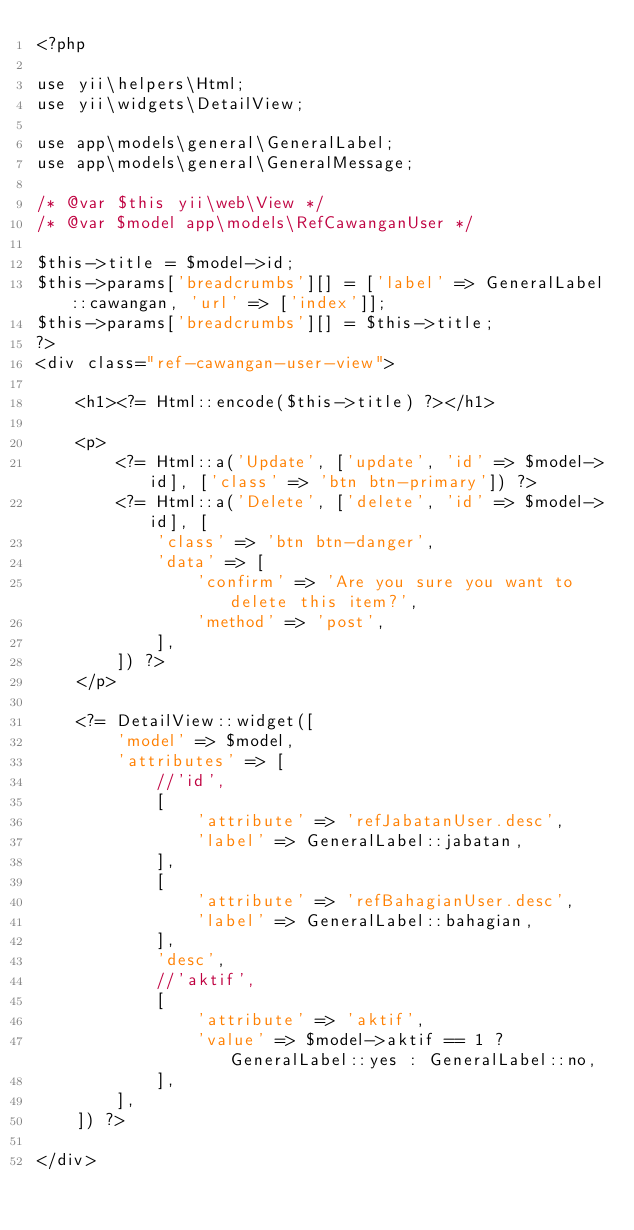<code> <loc_0><loc_0><loc_500><loc_500><_PHP_><?php

use yii\helpers\Html;
use yii\widgets\DetailView;

use app\models\general\GeneralLabel;
use app\models\general\GeneralMessage;

/* @var $this yii\web\View */
/* @var $model app\models\RefCawanganUser */

$this->title = $model->id;
$this->params['breadcrumbs'][] = ['label' => GeneralLabel::cawangan, 'url' => ['index']];
$this->params['breadcrumbs'][] = $this->title;
?>
<div class="ref-cawangan-user-view">

    <h1><?= Html::encode($this->title) ?></h1>

    <p>
        <?= Html::a('Update', ['update', 'id' => $model->id], ['class' => 'btn btn-primary']) ?>
        <?= Html::a('Delete', ['delete', 'id' => $model->id], [
            'class' => 'btn btn-danger',
            'data' => [
                'confirm' => 'Are you sure you want to delete this item?',
                'method' => 'post',
            ],
        ]) ?>
    </p>

    <?= DetailView::widget([
        'model' => $model,
        'attributes' => [
            //'id',
            [
                'attribute' => 'refJabatanUser.desc',
                'label' => GeneralLabel::jabatan,
            ],
            [
                'attribute' => 'refBahagianUser.desc',
                'label' => GeneralLabel::bahagian,
            ],
            'desc',
            //'aktif',
            [
                'attribute' => 'aktif',
                'value' => $model->aktif == 1 ? GeneralLabel::yes : GeneralLabel::no,
            ],
        ],
    ]) ?>

</div>
</code> 